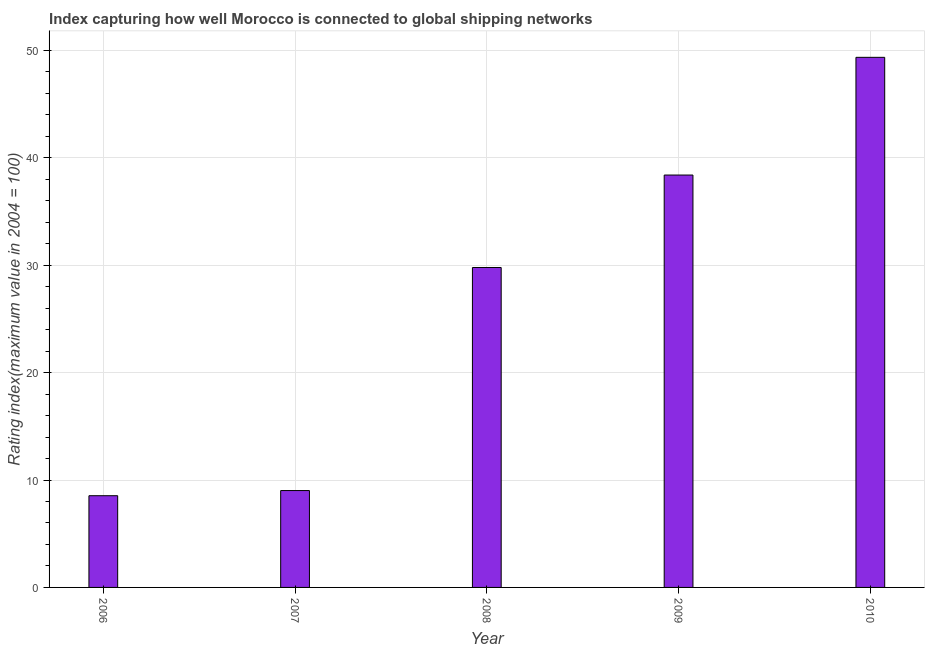Does the graph contain any zero values?
Keep it short and to the point. No. Does the graph contain grids?
Provide a short and direct response. Yes. What is the title of the graph?
Offer a terse response. Index capturing how well Morocco is connected to global shipping networks. What is the label or title of the Y-axis?
Provide a short and direct response. Rating index(maximum value in 2004 = 100). What is the liner shipping connectivity index in 2007?
Your response must be concise. 9.02. Across all years, what is the maximum liner shipping connectivity index?
Ensure brevity in your answer.  49.36. Across all years, what is the minimum liner shipping connectivity index?
Give a very brief answer. 8.54. What is the sum of the liner shipping connectivity index?
Ensure brevity in your answer.  135.11. What is the difference between the liner shipping connectivity index in 2006 and 2010?
Provide a succinct answer. -40.82. What is the average liner shipping connectivity index per year?
Provide a short and direct response. 27.02. What is the median liner shipping connectivity index?
Your response must be concise. 29.79. What is the ratio of the liner shipping connectivity index in 2008 to that in 2009?
Provide a short and direct response. 0.78. What is the difference between the highest and the second highest liner shipping connectivity index?
Provide a succinct answer. 10.96. Is the sum of the liner shipping connectivity index in 2006 and 2008 greater than the maximum liner shipping connectivity index across all years?
Ensure brevity in your answer.  No. What is the difference between the highest and the lowest liner shipping connectivity index?
Your response must be concise. 40.82. How many bars are there?
Give a very brief answer. 5. How many years are there in the graph?
Keep it short and to the point. 5. Are the values on the major ticks of Y-axis written in scientific E-notation?
Ensure brevity in your answer.  No. What is the Rating index(maximum value in 2004 = 100) of 2006?
Provide a short and direct response. 8.54. What is the Rating index(maximum value in 2004 = 100) of 2007?
Give a very brief answer. 9.02. What is the Rating index(maximum value in 2004 = 100) in 2008?
Make the answer very short. 29.79. What is the Rating index(maximum value in 2004 = 100) of 2009?
Offer a terse response. 38.4. What is the Rating index(maximum value in 2004 = 100) of 2010?
Ensure brevity in your answer.  49.36. What is the difference between the Rating index(maximum value in 2004 = 100) in 2006 and 2007?
Keep it short and to the point. -0.48. What is the difference between the Rating index(maximum value in 2004 = 100) in 2006 and 2008?
Your answer should be compact. -21.25. What is the difference between the Rating index(maximum value in 2004 = 100) in 2006 and 2009?
Your answer should be very brief. -29.86. What is the difference between the Rating index(maximum value in 2004 = 100) in 2006 and 2010?
Offer a terse response. -40.82. What is the difference between the Rating index(maximum value in 2004 = 100) in 2007 and 2008?
Make the answer very short. -20.77. What is the difference between the Rating index(maximum value in 2004 = 100) in 2007 and 2009?
Your answer should be compact. -29.38. What is the difference between the Rating index(maximum value in 2004 = 100) in 2007 and 2010?
Your answer should be very brief. -40.34. What is the difference between the Rating index(maximum value in 2004 = 100) in 2008 and 2009?
Offer a very short reply. -8.61. What is the difference between the Rating index(maximum value in 2004 = 100) in 2008 and 2010?
Offer a terse response. -19.57. What is the difference between the Rating index(maximum value in 2004 = 100) in 2009 and 2010?
Provide a short and direct response. -10.96. What is the ratio of the Rating index(maximum value in 2004 = 100) in 2006 to that in 2007?
Provide a succinct answer. 0.95. What is the ratio of the Rating index(maximum value in 2004 = 100) in 2006 to that in 2008?
Offer a very short reply. 0.29. What is the ratio of the Rating index(maximum value in 2004 = 100) in 2006 to that in 2009?
Your response must be concise. 0.22. What is the ratio of the Rating index(maximum value in 2004 = 100) in 2006 to that in 2010?
Provide a short and direct response. 0.17. What is the ratio of the Rating index(maximum value in 2004 = 100) in 2007 to that in 2008?
Provide a short and direct response. 0.3. What is the ratio of the Rating index(maximum value in 2004 = 100) in 2007 to that in 2009?
Your answer should be very brief. 0.23. What is the ratio of the Rating index(maximum value in 2004 = 100) in 2007 to that in 2010?
Your response must be concise. 0.18. What is the ratio of the Rating index(maximum value in 2004 = 100) in 2008 to that in 2009?
Your response must be concise. 0.78. What is the ratio of the Rating index(maximum value in 2004 = 100) in 2008 to that in 2010?
Ensure brevity in your answer.  0.6. What is the ratio of the Rating index(maximum value in 2004 = 100) in 2009 to that in 2010?
Make the answer very short. 0.78. 